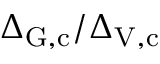Convert formula to latex. <formula><loc_0><loc_0><loc_500><loc_500>\Delta _ { G , c } / \Delta _ { V , c }</formula> 